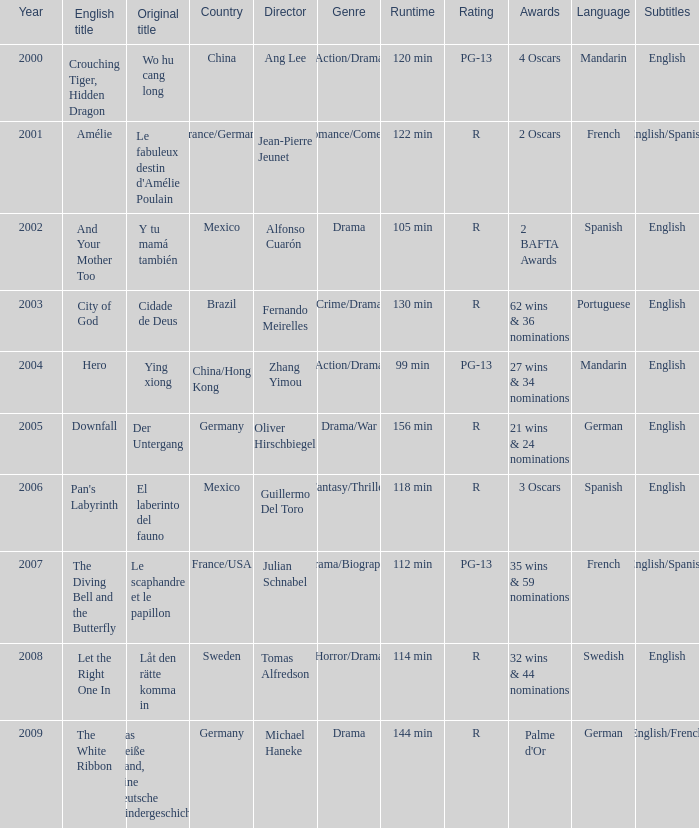Tell me the country for julian schnabel France/USA. 